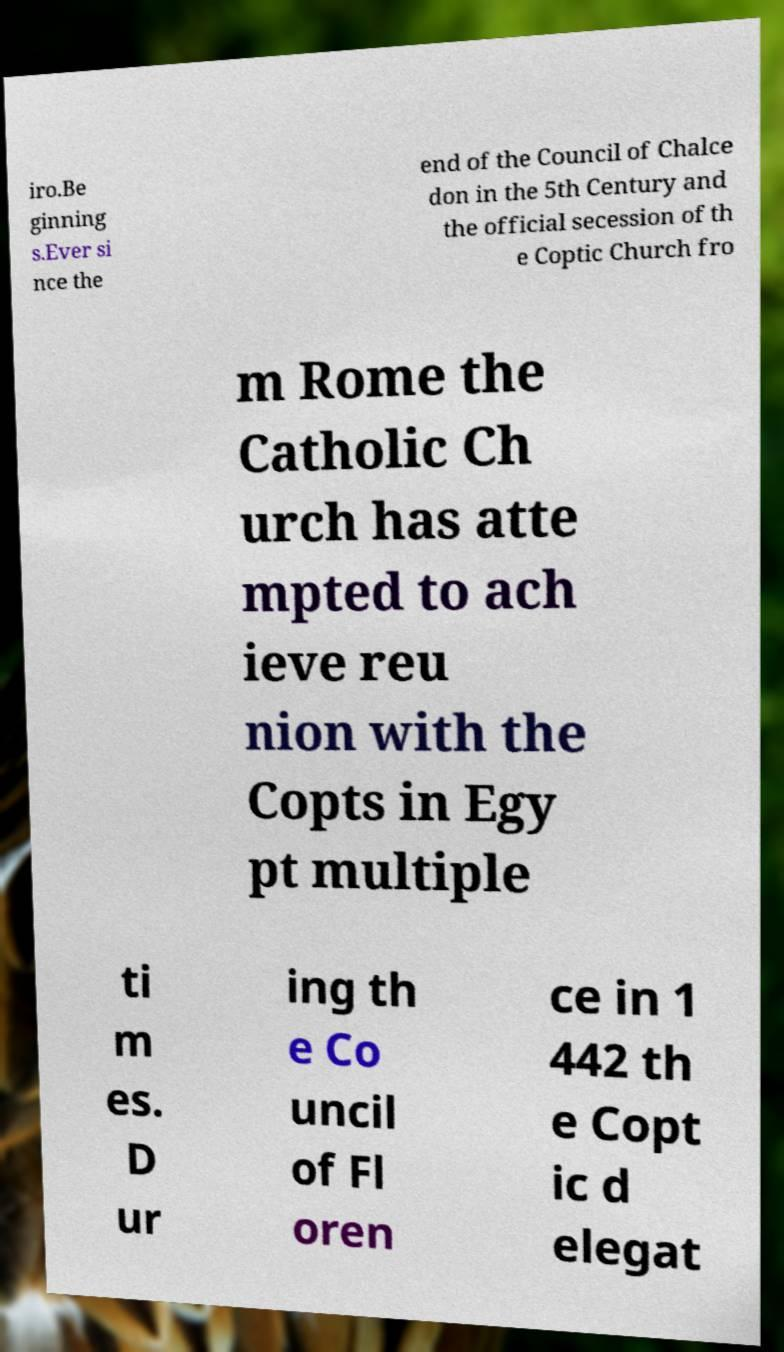Can you read and provide the text displayed in the image?This photo seems to have some interesting text. Can you extract and type it out for me? iro.Be ginning s.Ever si nce the end of the Council of Chalce don in the 5th Century and the official secession of th e Coptic Church fro m Rome the Catholic Ch urch has atte mpted to ach ieve reu nion with the Copts in Egy pt multiple ti m es. D ur ing th e Co uncil of Fl oren ce in 1 442 th e Copt ic d elegat 